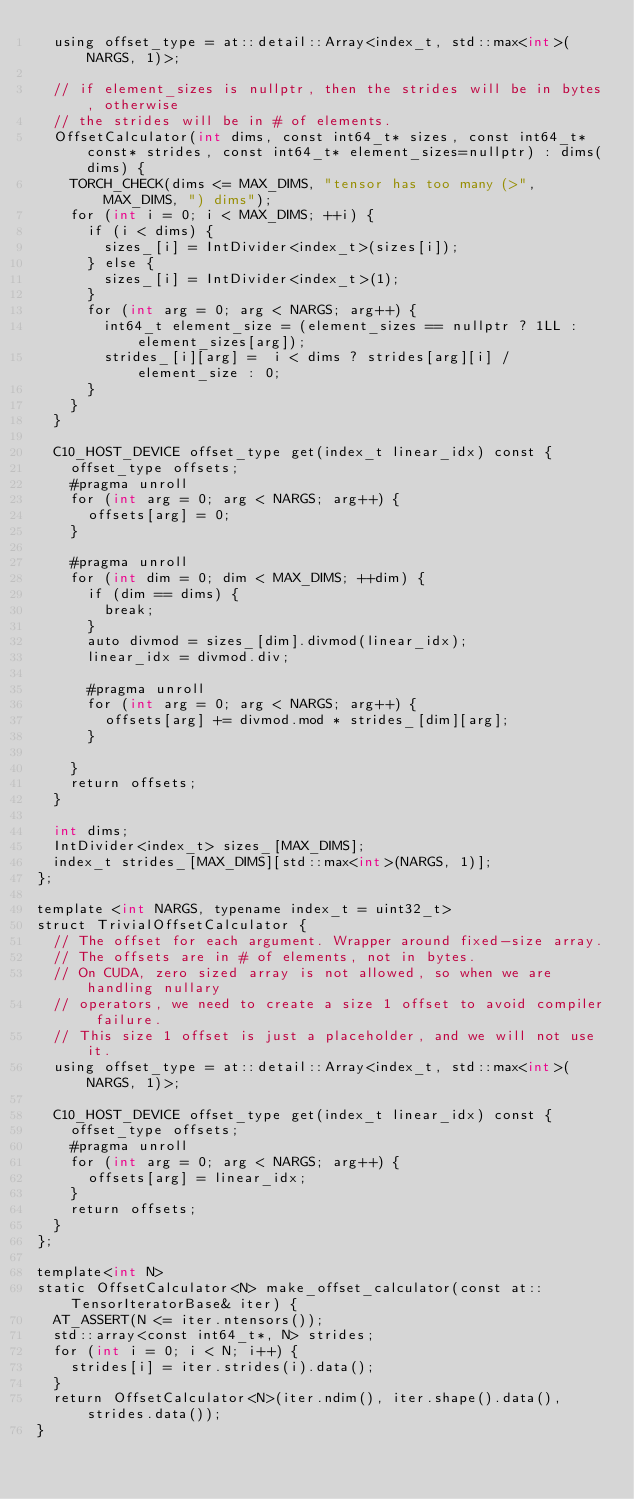Convert code to text. <code><loc_0><loc_0><loc_500><loc_500><_Cuda_>  using offset_type = at::detail::Array<index_t, std::max<int>(NARGS, 1)>;

  // if element_sizes is nullptr, then the strides will be in bytes, otherwise
  // the strides will be in # of elements.
  OffsetCalculator(int dims, const int64_t* sizes, const int64_t* const* strides, const int64_t* element_sizes=nullptr) : dims(dims) {
    TORCH_CHECK(dims <= MAX_DIMS, "tensor has too many (>", MAX_DIMS, ") dims");
    for (int i = 0; i < MAX_DIMS; ++i) {
      if (i < dims) {
        sizes_[i] = IntDivider<index_t>(sizes[i]);
      } else {
        sizes_[i] = IntDivider<index_t>(1);
      }
      for (int arg = 0; arg < NARGS; arg++) {
        int64_t element_size = (element_sizes == nullptr ? 1LL : element_sizes[arg]);
        strides_[i][arg] =  i < dims ? strides[arg][i] / element_size : 0;
      }
    }
  }

  C10_HOST_DEVICE offset_type get(index_t linear_idx) const {
    offset_type offsets;
    #pragma unroll
    for (int arg = 0; arg < NARGS; arg++) {
      offsets[arg] = 0;
    }

    #pragma unroll
    for (int dim = 0; dim < MAX_DIMS; ++dim) {
      if (dim == dims) {
        break;
      }
      auto divmod = sizes_[dim].divmod(linear_idx);
      linear_idx = divmod.div;

      #pragma unroll
      for (int arg = 0; arg < NARGS; arg++) {
        offsets[arg] += divmod.mod * strides_[dim][arg];
      }

    }
    return offsets;
  }

  int dims;
  IntDivider<index_t> sizes_[MAX_DIMS];
  index_t strides_[MAX_DIMS][std::max<int>(NARGS, 1)];
};

template <int NARGS, typename index_t = uint32_t>
struct TrivialOffsetCalculator {
  // The offset for each argument. Wrapper around fixed-size array.
  // The offsets are in # of elements, not in bytes.
  // On CUDA, zero sized array is not allowed, so when we are handling nullary
  // operators, we need to create a size 1 offset to avoid compiler failure.
  // This size 1 offset is just a placeholder, and we will not use it.
  using offset_type = at::detail::Array<index_t, std::max<int>(NARGS, 1)>;

  C10_HOST_DEVICE offset_type get(index_t linear_idx) const {
    offset_type offsets;
    #pragma unroll
    for (int arg = 0; arg < NARGS; arg++) {
      offsets[arg] = linear_idx;
    }
    return offsets;
  }
};

template<int N>
static OffsetCalculator<N> make_offset_calculator(const at::TensorIteratorBase& iter) {
  AT_ASSERT(N <= iter.ntensors());
  std::array<const int64_t*, N> strides;
  for (int i = 0; i < N; i++) {
    strides[i] = iter.strides(i).data();
  }
  return OffsetCalculator<N>(iter.ndim(), iter.shape().data(), strides.data());
}
</code> 